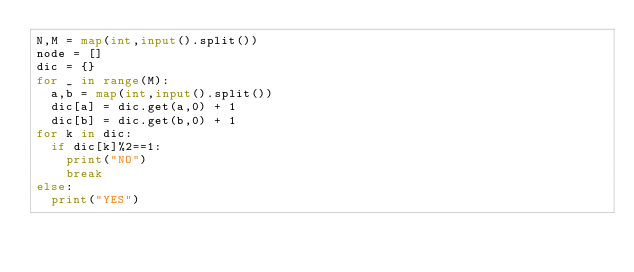Convert code to text. <code><loc_0><loc_0><loc_500><loc_500><_Python_>N,M = map(int,input().split())
node = [] 
dic = {}
for _ in range(M):
  a,b = map(int,input().split())
  dic[a] = dic.get(a,0) + 1
  dic[b] = dic.get(b,0) + 1
for k in dic:
  if dic[k]%2==1:
    print("NO")
    break
else:
  print("YES")
  
  </code> 